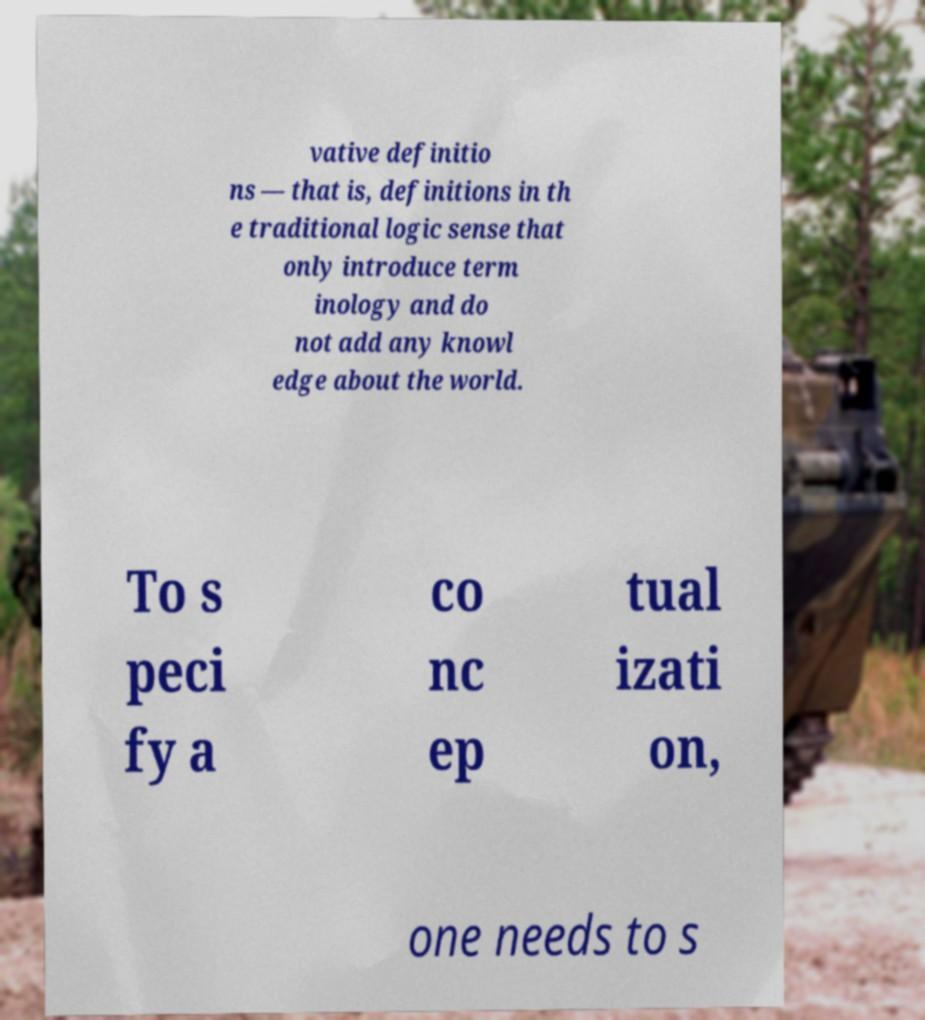Could you assist in decoding the text presented in this image and type it out clearly? vative definitio ns — that is, definitions in th e traditional logic sense that only introduce term inology and do not add any knowl edge about the world. To s peci fy a co nc ep tual izati on, one needs to s 